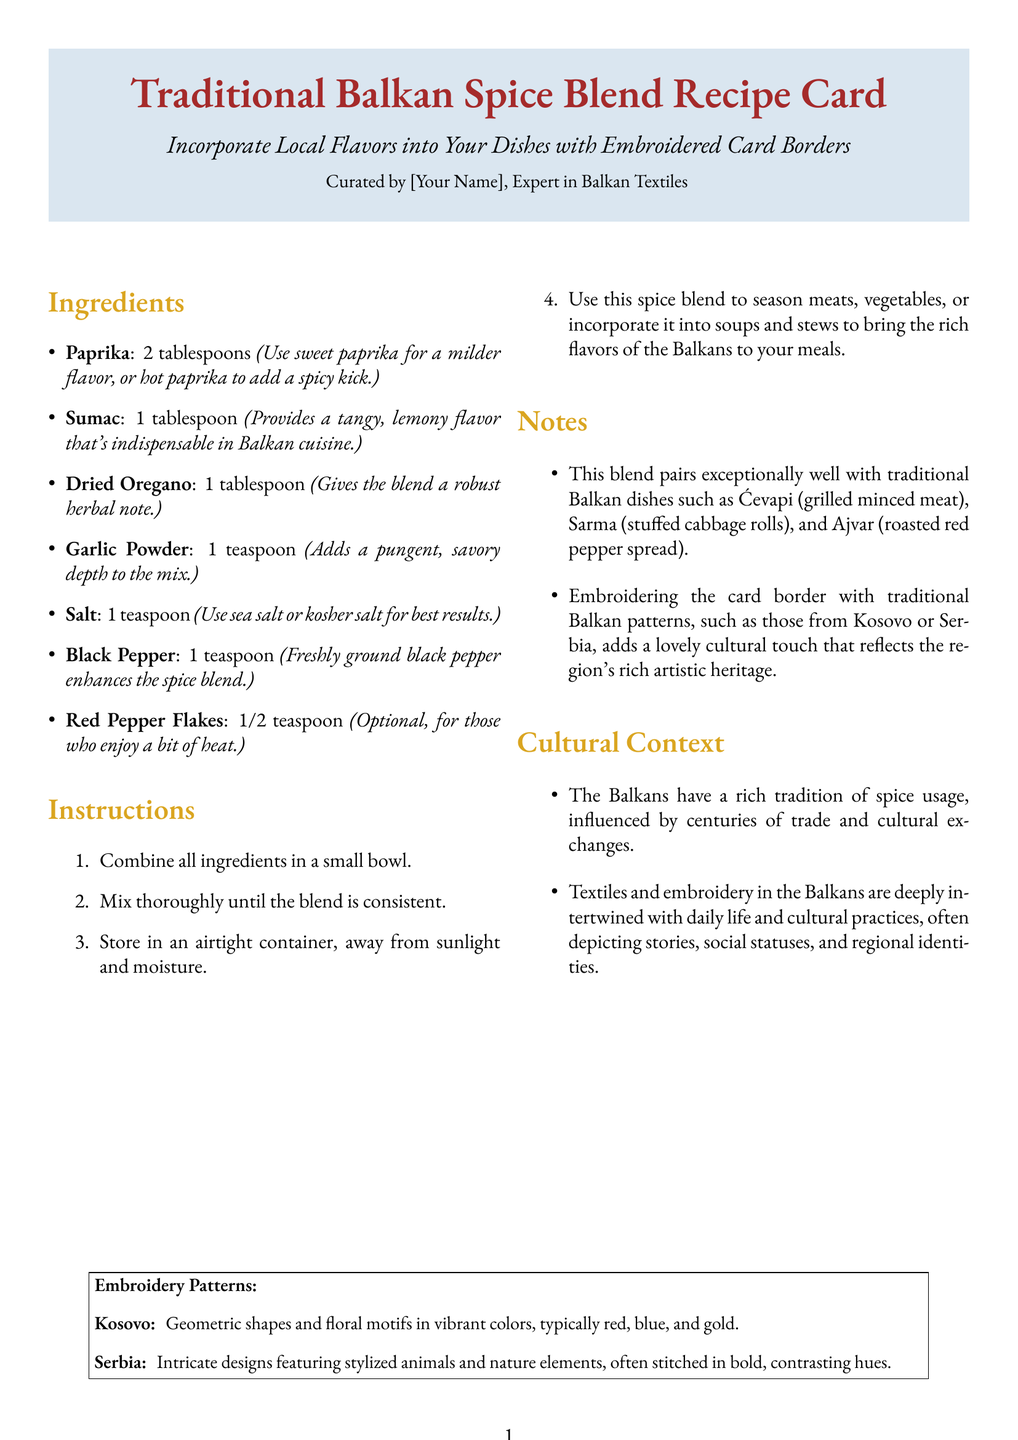What is the title of the recipe card? The title is prominently displayed in large font at the top of the document.
Answer: Traditional Balkan Spice Blend Recipe Card How many tablespoons of paprika are needed? The ingredients list specifies the amount of paprika required for the spice blend.
Answer: 2 tablespoons What is the optional ingredient for added heat? The ingredients list highlights an optional element that can enhance spiciness.
Answer: Red Pepper Flakes What type of containers should the blend be stored in? The instructions mention the storage requirements for the spice blend.
Answer: Airtight container Which dish pairs exceptionally well with the spice blend? The notes provide examples of traditional Balkan dishes that complement the blend.
Answer: Ćevapi What motif is common in Kosovo embroidery patterns? The document describes specific details for embroidery patterns associated with Kosovo.
Answer: Geometric shapes How many ingredients are listed for the spice blend? By counting the items under the ingredients section, one can determine the total.
Answer: 7 What do the textiles in the Balkans often depict? The cultural context section outlines the significance of textiles in Balkan culture.
Answer: Stories, social statuses, and regional identities 